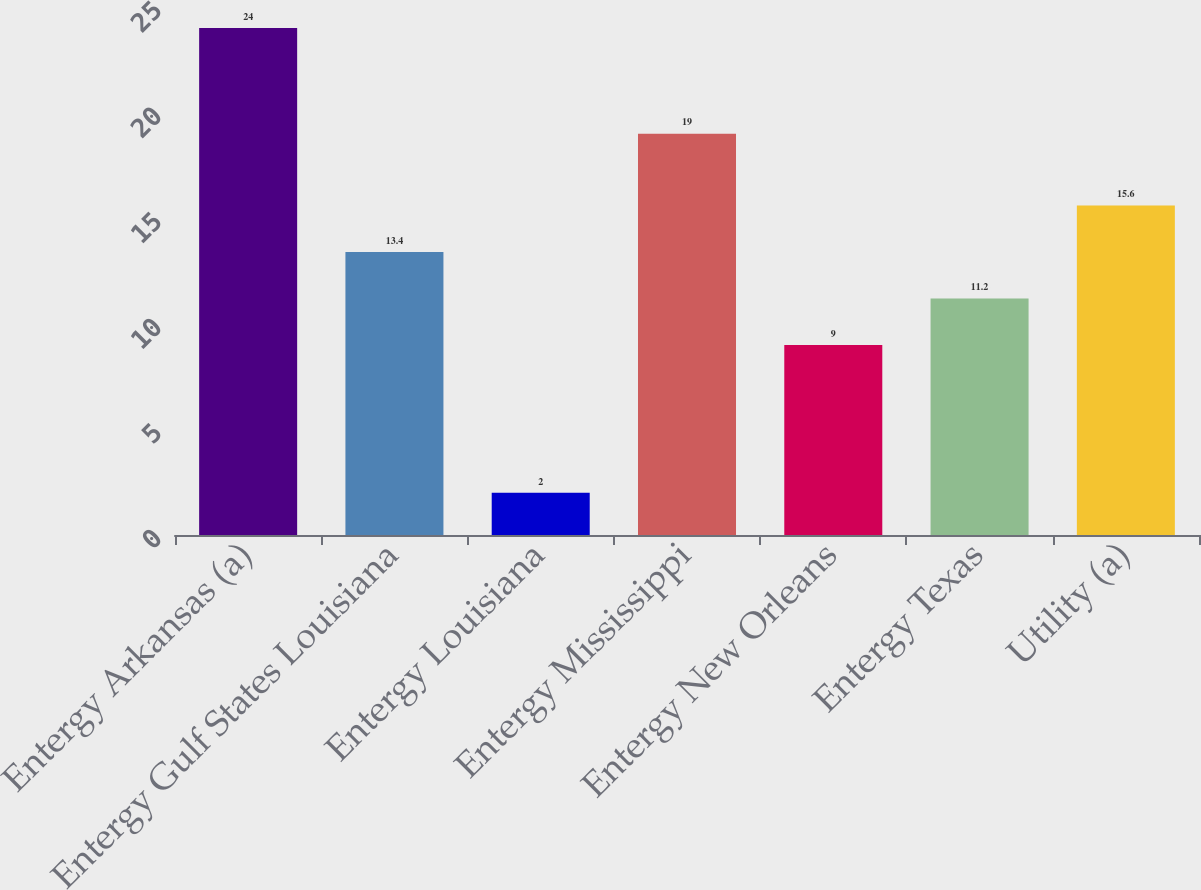Convert chart. <chart><loc_0><loc_0><loc_500><loc_500><bar_chart><fcel>Entergy Arkansas (a)<fcel>Entergy Gulf States Louisiana<fcel>Entergy Louisiana<fcel>Entergy Mississippi<fcel>Entergy New Orleans<fcel>Entergy Texas<fcel>Utility (a)<nl><fcel>24<fcel>13.4<fcel>2<fcel>19<fcel>9<fcel>11.2<fcel>15.6<nl></chart> 